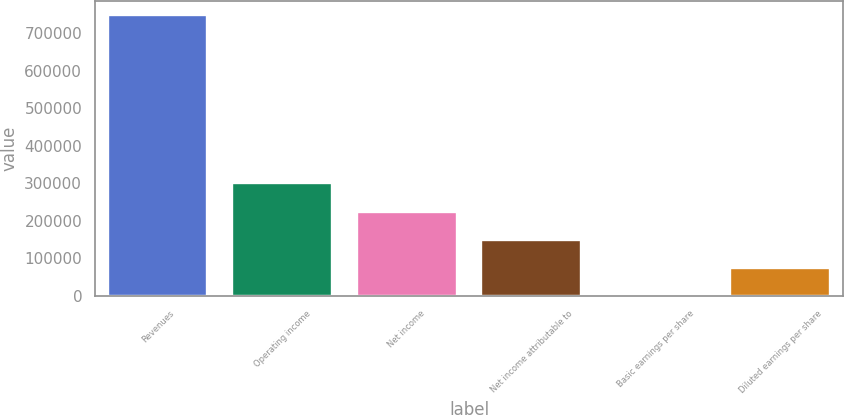Convert chart. <chart><loc_0><loc_0><loc_500><loc_500><bar_chart><fcel>Revenues<fcel>Operating income<fcel>Net income<fcel>Net income attributable to<fcel>Basic earnings per share<fcel>Diluted earnings per share<nl><fcel>748796<fcel>299519<fcel>224639<fcel>149760<fcel>0.66<fcel>74880.2<nl></chart> 